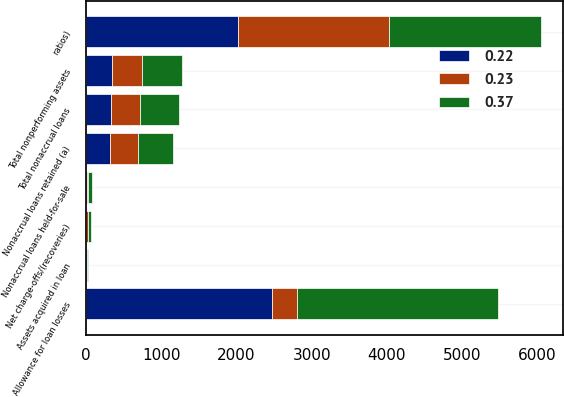Convert chart to OTSL. <chart><loc_0><loc_0><loc_500><loc_500><stacked_bar_chart><ecel><fcel>ratios)<fcel>Net charge-offs/(recoveries)<fcel>Nonaccrual loans retained (a)<fcel>Nonaccrual loans held-for-sale<fcel>Total nonaccrual loans<fcel>Assets acquired in loan<fcel>Total nonperforming assets<fcel>Allowance for loan losses<nl><fcel>0.23<fcel>2015<fcel>21<fcel>375<fcel>18<fcel>393<fcel>8<fcel>401<fcel>341<nl><fcel>0.22<fcel>2014<fcel>7<fcel>317<fcel>14<fcel>331<fcel>10<fcel>341<fcel>2466<nl><fcel>0.37<fcel>2013<fcel>43<fcel>471<fcel>43<fcel>514<fcel>15<fcel>529<fcel>2669<nl></chart> 